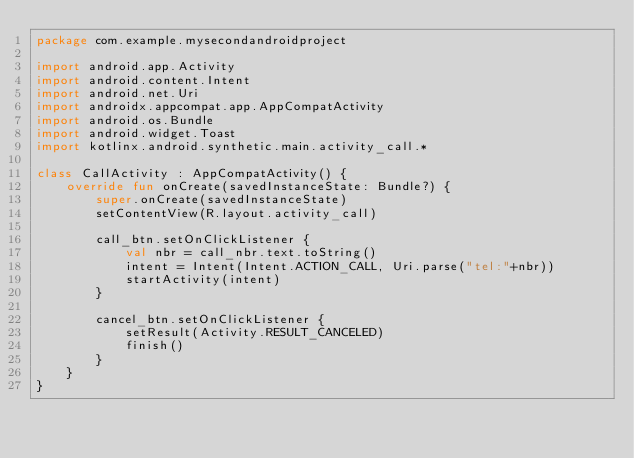<code> <loc_0><loc_0><loc_500><loc_500><_Kotlin_>package com.example.mysecondandroidproject

import android.app.Activity
import android.content.Intent
import android.net.Uri
import androidx.appcompat.app.AppCompatActivity
import android.os.Bundle
import android.widget.Toast
import kotlinx.android.synthetic.main.activity_call.*

class CallActivity : AppCompatActivity() {
    override fun onCreate(savedInstanceState: Bundle?) {
        super.onCreate(savedInstanceState)
        setContentView(R.layout.activity_call)

        call_btn.setOnClickListener {
            val nbr = call_nbr.text.toString()
            intent = Intent(Intent.ACTION_CALL, Uri.parse("tel:"+nbr))
            startActivity(intent)
        }

        cancel_btn.setOnClickListener {
            setResult(Activity.RESULT_CANCELED)
            finish()
        }
    }
}</code> 